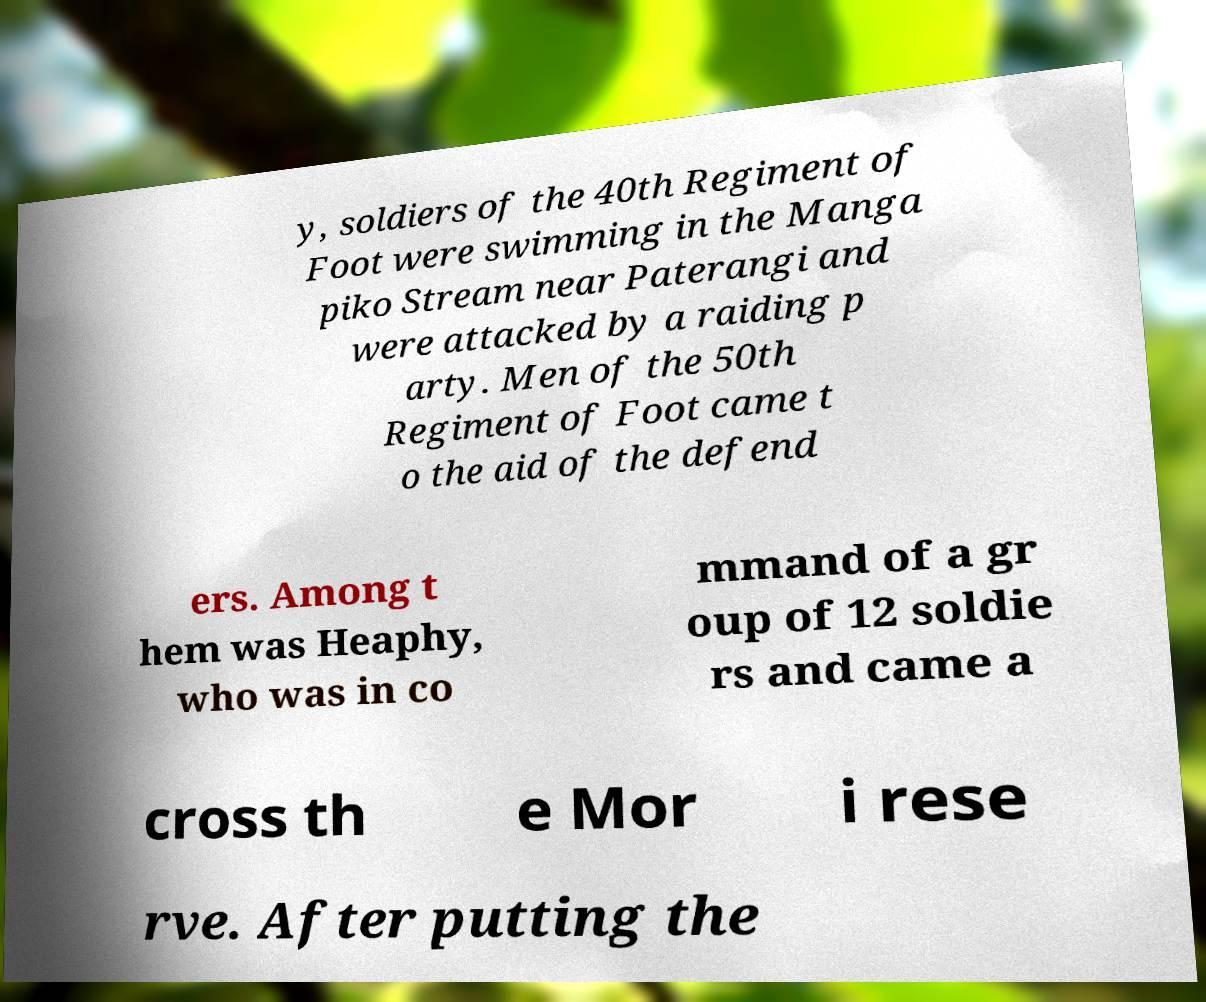I need the written content from this picture converted into text. Can you do that? y, soldiers of the 40th Regiment of Foot were swimming in the Manga piko Stream near Paterangi and were attacked by a raiding p arty. Men of the 50th Regiment of Foot came t o the aid of the defend ers. Among t hem was Heaphy, who was in co mmand of a gr oup of 12 soldie rs and came a cross th e Mor i rese rve. After putting the 